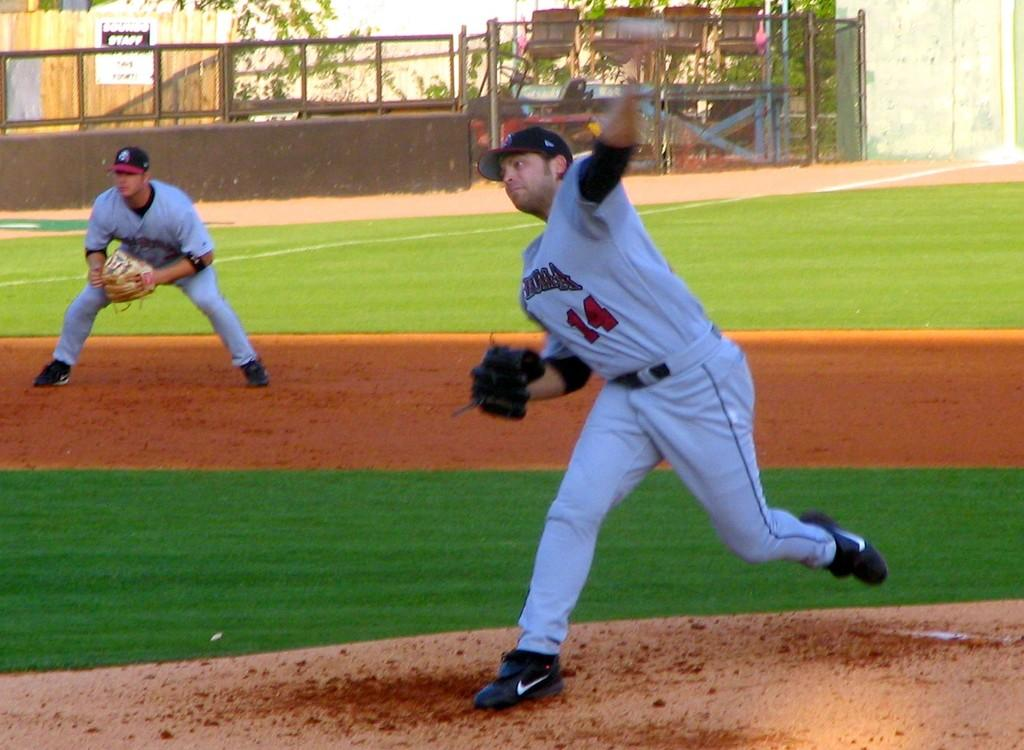Provide a one-sentence caption for the provided image. Player number 14 on the baseball team goes to pitch the ball. 